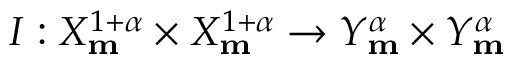Convert formula to latex. <formula><loc_0><loc_0><loc_500><loc_500>I \colon X _ { m } ^ { 1 + \alpha } \times X _ { m } ^ { 1 + \alpha } \rightarrow Y _ { m } ^ { \alpha } \times Y _ { m } ^ { \alpha }</formula> 